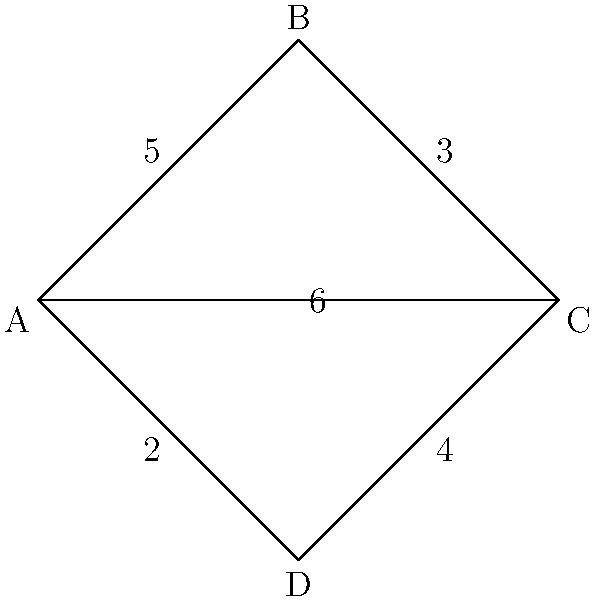You want to create an infographic to visualize the connections between different departments in your startup. The graph above represents these connections, where vertices are departments and edge weights indicate the strength of collaboration. What is the minimum number of edges you need to highlight to ensure all departments are connected while minimizing the total weight? To solve this problem, we need to find the Minimum Spanning Tree (MST) of the graph. The MST is a subset of edges that connects all vertices with the minimum total weight. We can use Kruskal's algorithm to find the MST:

1. Sort all edges by weight in ascending order:
   AD (2), AB (5), BC (3), CD (4), AC (6)

2. Start with an empty set of edges and add edges one by one:
   a. Add AD (2)
   b. Add BC (3)
   c. Add AB (5) - This connects all vertices

3. We don't need to consider CD (4) or AC (6) as all vertices are already connected.

The MST consists of edges AD, BC, and AB, with a total weight of 2 + 3 + 5 = 10.

Therefore, the minimum number of edges needed to connect all departments while minimizing the total weight is 3.
Answer: 3 edges 